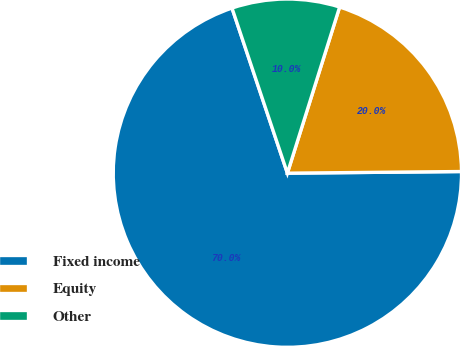Convert chart to OTSL. <chart><loc_0><loc_0><loc_500><loc_500><pie_chart><fcel>Fixed income<fcel>Equity<fcel>Other<nl><fcel>70.0%<fcel>20.0%<fcel>10.0%<nl></chart> 